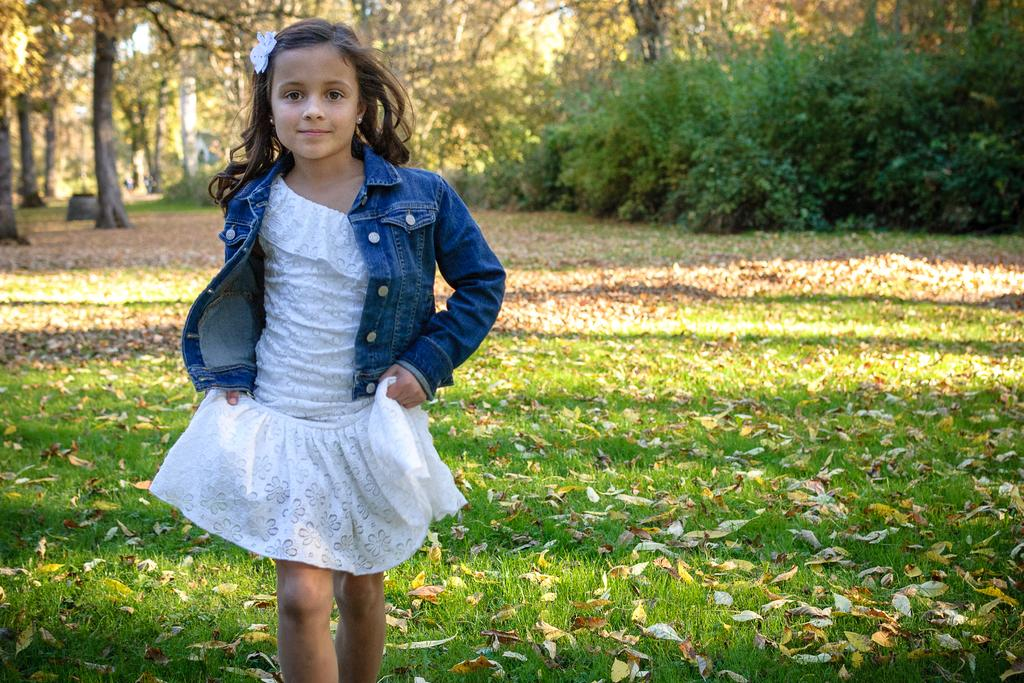Who is the main subject in the image? There is a girl in the image. What is the girl doing in the image? The girl is walking on the grass. What type of vegetation can be seen in the image? Bushes and trees are present in the image. What is the condition of the ground in the image? Shredded leaves are visible in the image. What is visible in the background of the image? The sky is visible in the image. Can you tell me how many times the girl kicks the net in the image? There is no net present in the image, and therefore no such activity can be observed. 